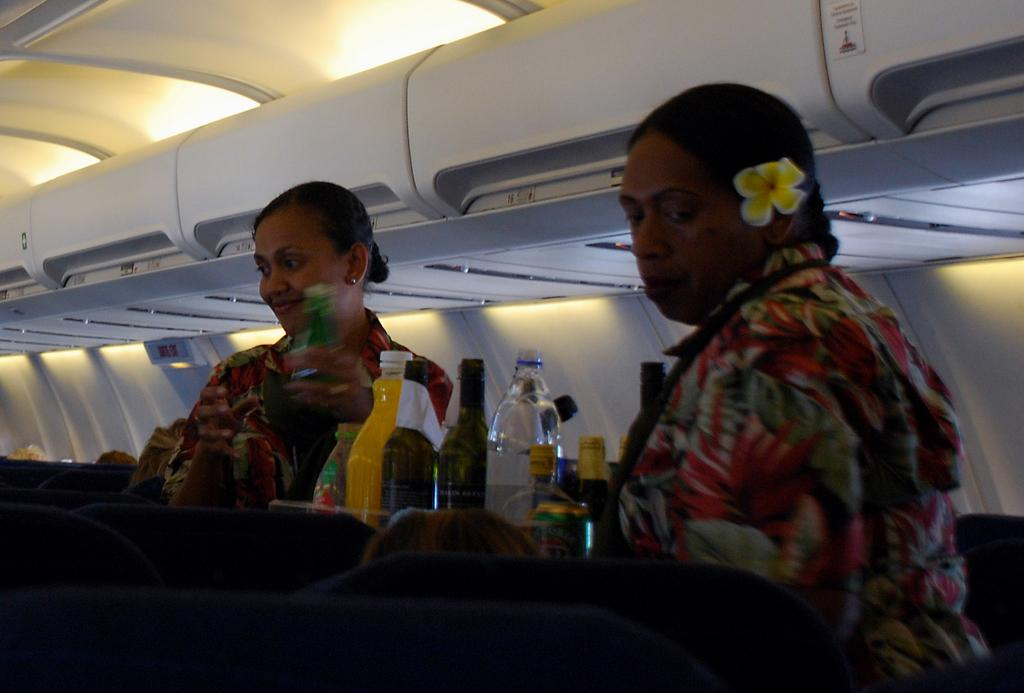What type of location is depicted in the image? The image shows an inside view of an airplane. Can you describe the people in the image? There are two women standing in the image. What objects can be seen in the image? There are bottles visible in the image. What type of prose is being read by the women in the image? There is no indication in the image that the women are reading any prose, as the focus is on their presence in the airplane. --- Facts: 1. There is a person sitting on a bench in the image. 2. The person is reading a book. 3. There is a tree in the background of the image. 4. The sky is visible in the image. Absurd Topics: dance, parrot, bicycle Conversation: What is the person in the image doing? The person is sitting on a bench in the image. What activity is the person engaged in while sitting on the bench? The person is reading a book. What can be seen in the background of the image? There is a tree in the background of the image. What else is visible in the image? The sky is visible in the image. Reasoning: Let's think step by step in order to produce the conversation. We start by identifying the main subject of the image, which is the person sitting on a bench. Then, we describe the activity the person is engaged in, which is reading a book. Next, we mention the background elements, including the tree and the sky. Absurd Question/Answer: What type of dance is the person performing on the bench in the image? There is no indication in the image that the person is dancing, as they are sitting and reading a book. --- Facts: 1. There is a car in the image. 2. The car is parked on the street. 3. There are buildings in the background of the image. 4. The sky is visible in the image. Absurd Topics: elephant, piano, rainbow Conversation: What is the main subject of the image? The main subject of the image is a car. Where is the car located in the image? The car is parked on the street. What can be seen in the background of the image? There are buildings in the background of the image. What else is visible in the image? The sky is visible in the image. Reasoning: Let's think step by step in order to produce the conversation. We start by identifying the main subject of the image, which is the car. Then, we describe the location of the car, noting that it is parked on the street. Next, we mention the background elements, including the buildings and the sky. Absurd Question/Answer: Can you tell me how many elephants are standing next to the car in the image? There are no elephants present in the 